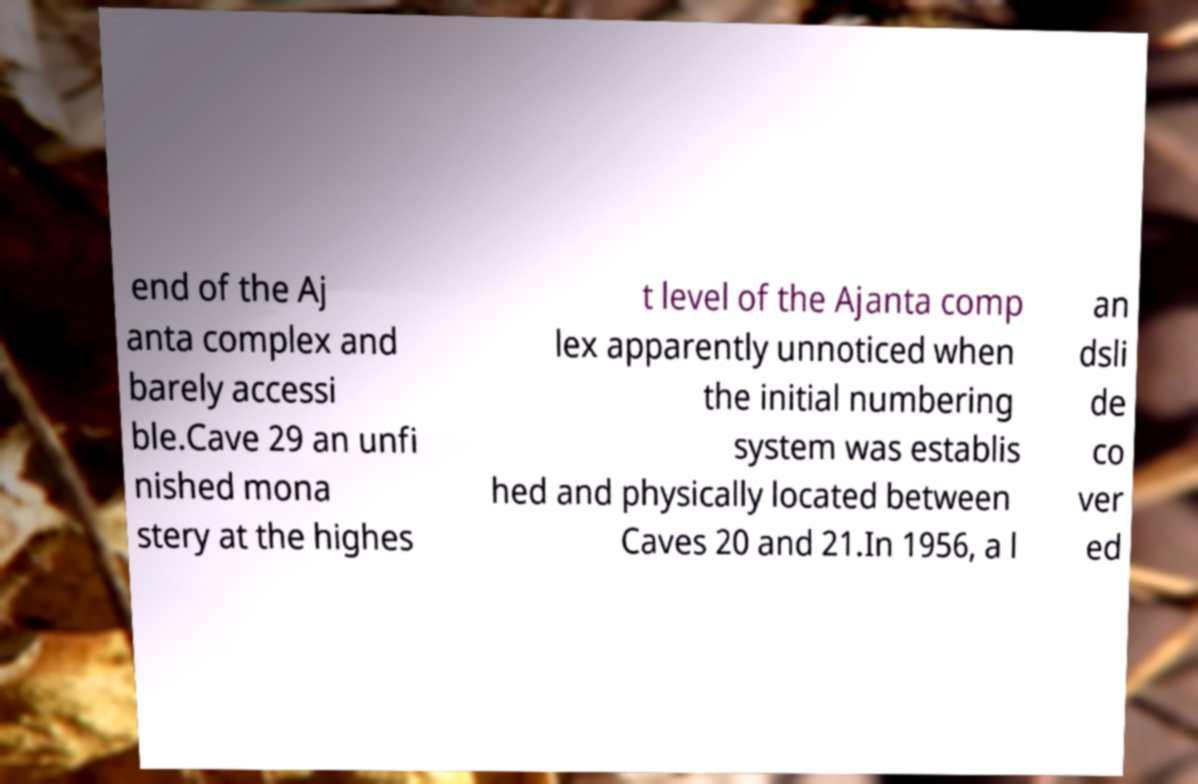Could you extract and type out the text from this image? end of the Aj anta complex and barely accessi ble.Cave 29 an unfi nished mona stery at the highes t level of the Ajanta comp lex apparently unnoticed when the initial numbering system was establis hed and physically located between Caves 20 and 21.In 1956, a l an dsli de co ver ed 